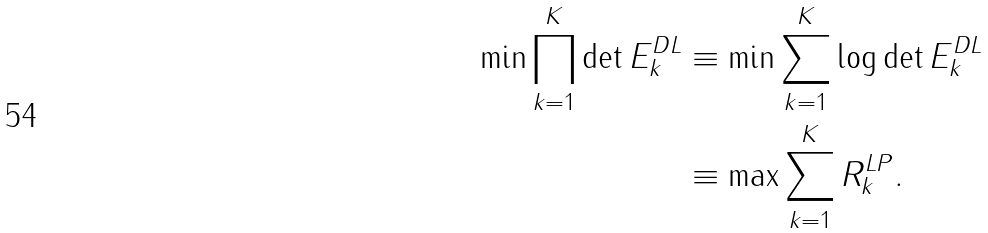Convert formula to latex. <formula><loc_0><loc_0><loc_500><loc_500>\min \prod _ { k = 1 } ^ { K } \det E ^ { D L } _ { k } & \equiv \min \sum _ { k = 1 } ^ { K } \log \det E ^ { D L } _ { k } \\ & \equiv \max \sum _ { k = 1 } ^ { K } R ^ { L P } _ { k } .</formula> 